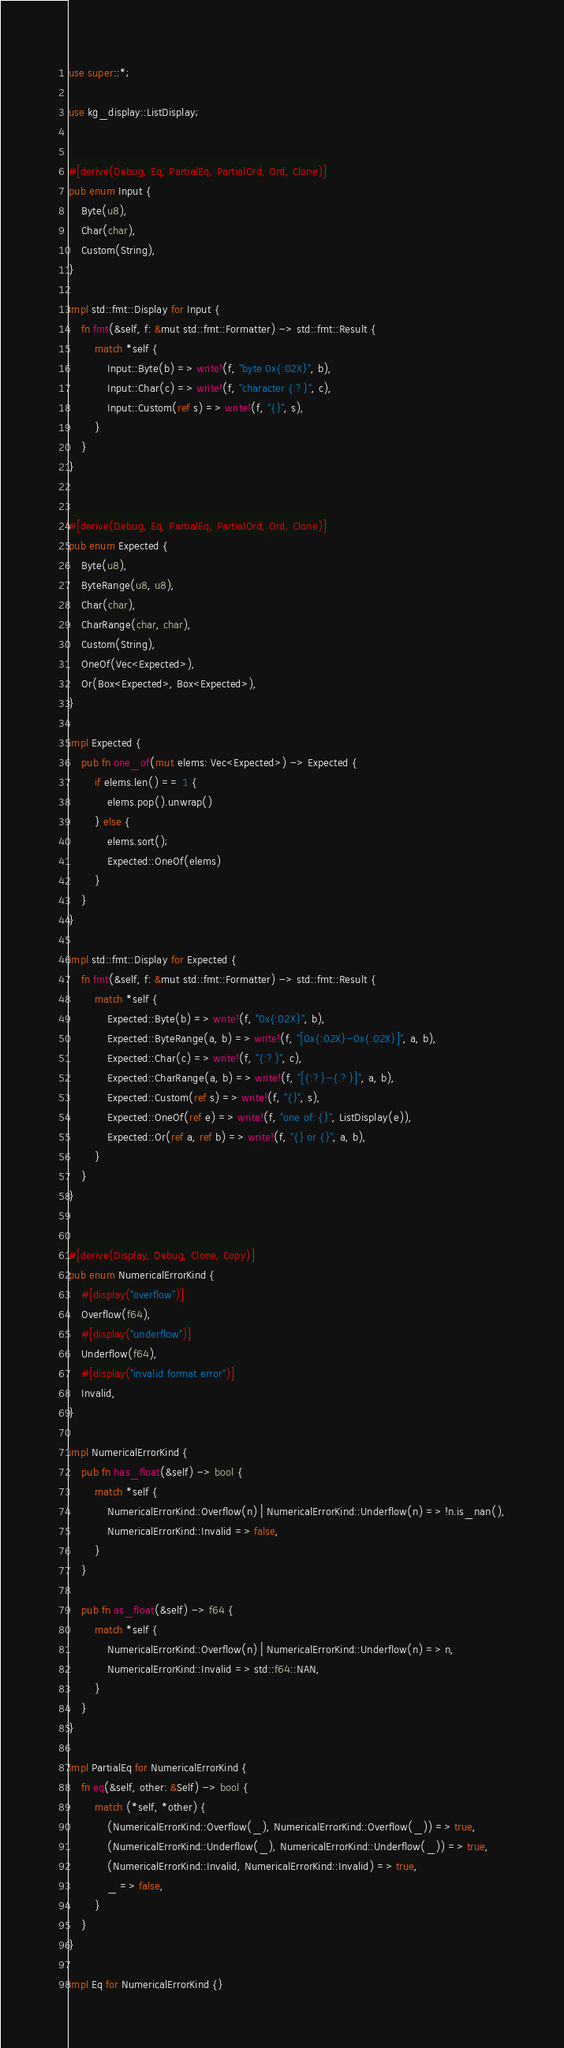<code> <loc_0><loc_0><loc_500><loc_500><_Rust_>use super::*;

use kg_display::ListDisplay;


#[derive(Debug, Eq, PartialEq, PartialOrd, Ord, Clone)]
pub enum Input {
    Byte(u8),
    Char(char),
    Custom(String),
}

impl std::fmt::Display for Input {
    fn fmt(&self, f: &mut std::fmt::Formatter) -> std::fmt::Result {
        match *self {
            Input::Byte(b) => write!(f, "byte 0x{:02X}", b),
            Input::Char(c) => write!(f, "character {:?}", c),
            Input::Custom(ref s) => write!(f, "{}", s),
        }
    }
}


#[derive(Debug, Eq, PartialEq, PartialOrd, Ord, Clone)]
pub enum Expected {
    Byte(u8),
    ByteRange(u8, u8),
    Char(char),
    CharRange(char, char),
    Custom(String),
    OneOf(Vec<Expected>),
    Or(Box<Expected>, Box<Expected>),
}

impl Expected {
    pub fn one_of(mut elems: Vec<Expected>) -> Expected {
        if elems.len() == 1 {
            elems.pop().unwrap()
        } else {
            elems.sort();
            Expected::OneOf(elems)
        }
    }
}

impl std::fmt::Display for Expected {
    fn fmt(&self, f: &mut std::fmt::Formatter) -> std::fmt::Result {
        match *self {
            Expected::Byte(b) => write!(f, "0x{:02X}", b),
            Expected::ByteRange(a, b) => write!(f, "[0x{:02X}-0x{:02X}]", a, b),
            Expected::Char(c) => write!(f, "{:?}", c),
            Expected::CharRange(a, b) => write!(f, "[{:?}-{:?}]", a, b),
            Expected::Custom(ref s) => write!(f, "{}", s),
            Expected::OneOf(ref e) => write!(f, "one of: {}", ListDisplay(e)),
            Expected::Or(ref a, ref b) => write!(f, "{} or {}", a, b),
        }
    }
}


#[derive(Display, Debug, Clone, Copy)]
pub enum NumericalErrorKind {
    #[display("overflow")]
    Overflow(f64),
    #[display("underflow")]
    Underflow(f64),
    #[display("invalid format error")]
    Invalid,
}

impl NumericalErrorKind {
    pub fn has_float(&self) -> bool {
        match *self {
            NumericalErrorKind::Overflow(n) | NumericalErrorKind::Underflow(n) => !n.is_nan(),
            NumericalErrorKind::Invalid => false,
        }
    }

    pub fn as_float(&self) -> f64 {
        match *self {
            NumericalErrorKind::Overflow(n) | NumericalErrorKind::Underflow(n) => n,
            NumericalErrorKind::Invalid => std::f64::NAN,
        }
    }
}

impl PartialEq for NumericalErrorKind {
    fn eq(&self, other: &Self) -> bool {
        match (*self, *other) {
            (NumericalErrorKind::Overflow(_), NumericalErrorKind::Overflow(_)) => true,
            (NumericalErrorKind::Underflow(_), NumericalErrorKind::Underflow(_)) => true,
            (NumericalErrorKind::Invalid, NumericalErrorKind::Invalid) => true,
            _ => false,
        }
    }
}

impl Eq for NumericalErrorKind {}

</code> 